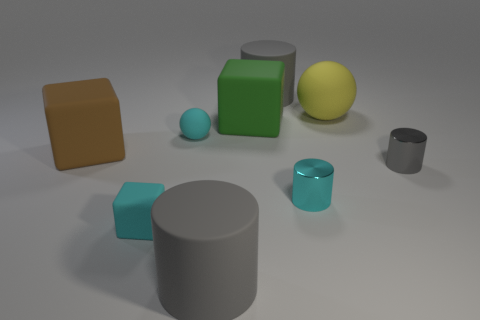What number of other objects are the same shape as the yellow matte object?
Your response must be concise. 1. How many green objects have the same size as the green rubber cube?
Make the answer very short. 0. There is a big green object that is the same shape as the big brown matte object; what material is it?
Make the answer very short. Rubber. What is the color of the big matte thing that is behind the large sphere?
Offer a very short reply. Gray. Are there more small cyan rubber objects that are behind the cyan cylinder than big blue matte cubes?
Offer a very short reply. Yes. The small sphere is what color?
Give a very brief answer. Cyan. What is the shape of the cyan thing that is on the right side of the big gray matte thing that is left of the gray rubber cylinder behind the small gray metal cylinder?
Your answer should be compact. Cylinder. There is a cube that is behind the small gray object and right of the large brown rubber object; what is it made of?
Your answer should be compact. Rubber. There is a large matte thing on the left side of the small cyan object that is behind the gray metal thing; what is its shape?
Keep it short and to the point. Cube. Are there any other things that are the same color as the small block?
Ensure brevity in your answer.  Yes. 